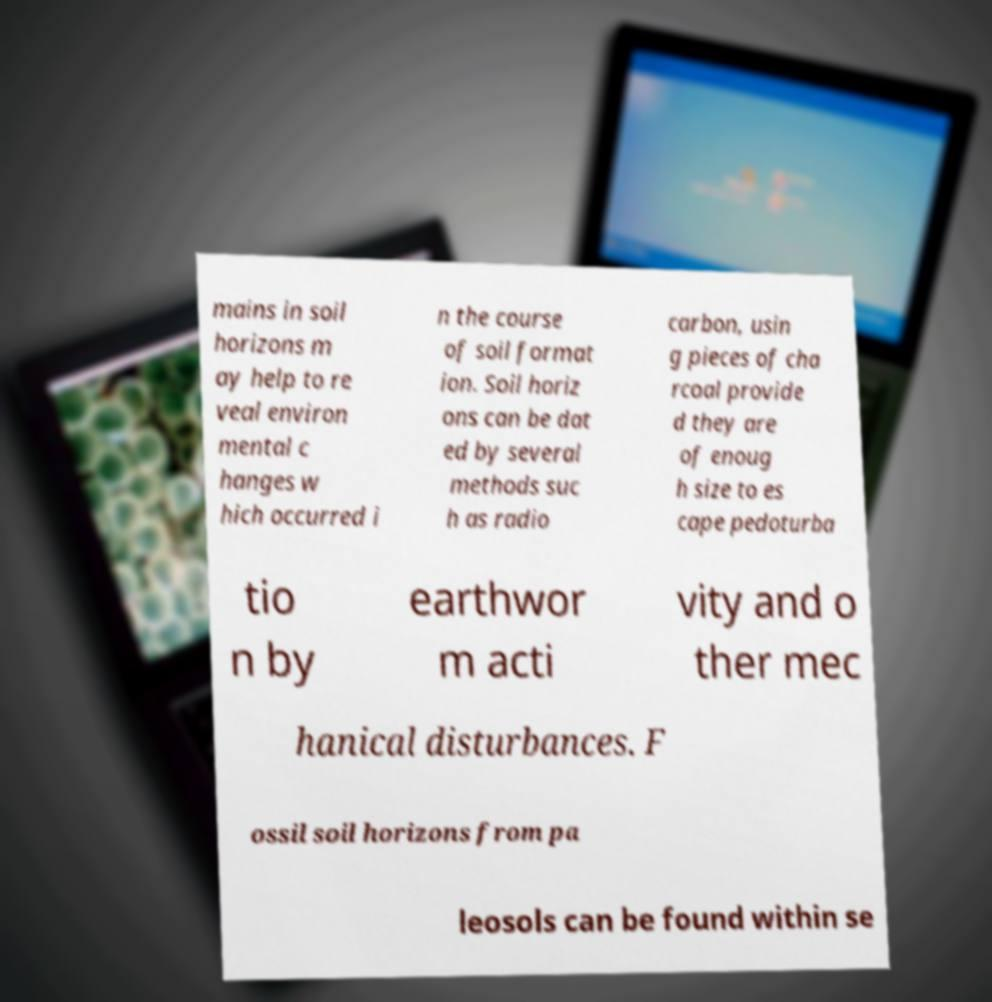Can you read and provide the text displayed in the image?This photo seems to have some interesting text. Can you extract and type it out for me? mains in soil horizons m ay help to re veal environ mental c hanges w hich occurred i n the course of soil format ion. Soil horiz ons can be dat ed by several methods suc h as radio carbon, usin g pieces of cha rcoal provide d they are of enoug h size to es cape pedoturba tio n by earthwor m acti vity and o ther mec hanical disturbances. F ossil soil horizons from pa leosols can be found within se 